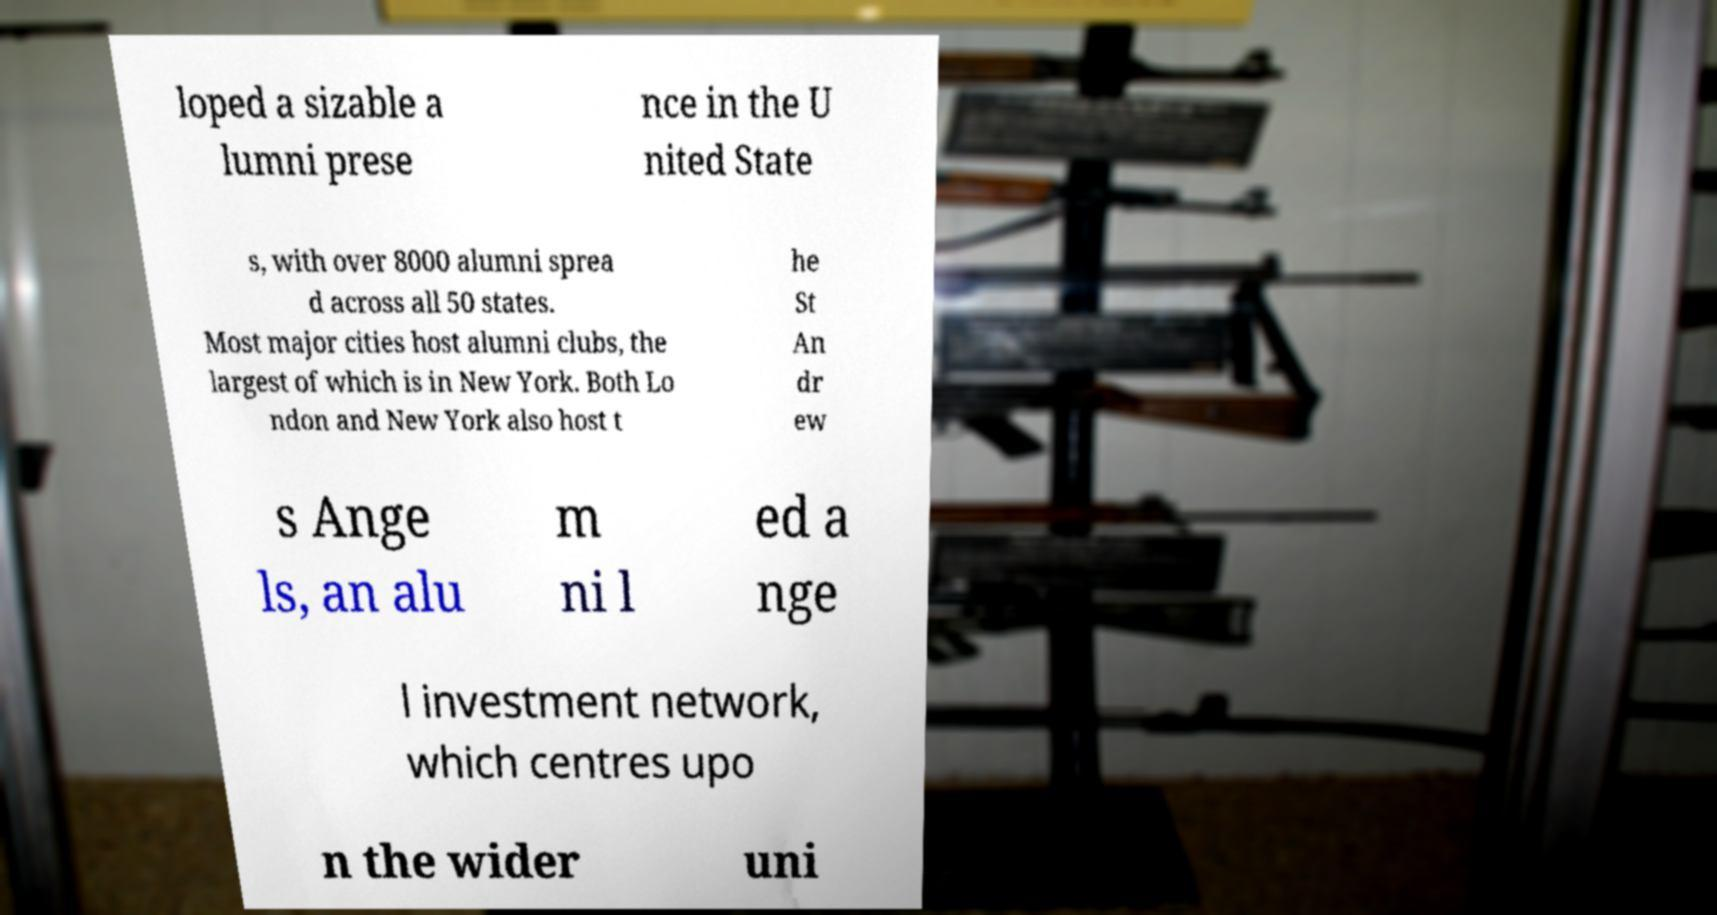Can you accurately transcribe the text from the provided image for me? loped a sizable a lumni prese nce in the U nited State s, with over 8000 alumni sprea d across all 50 states. Most major cities host alumni clubs, the largest of which is in New York. Both Lo ndon and New York also host t he St An dr ew s Ange ls, an alu m ni l ed a nge l investment network, which centres upo n the wider uni 